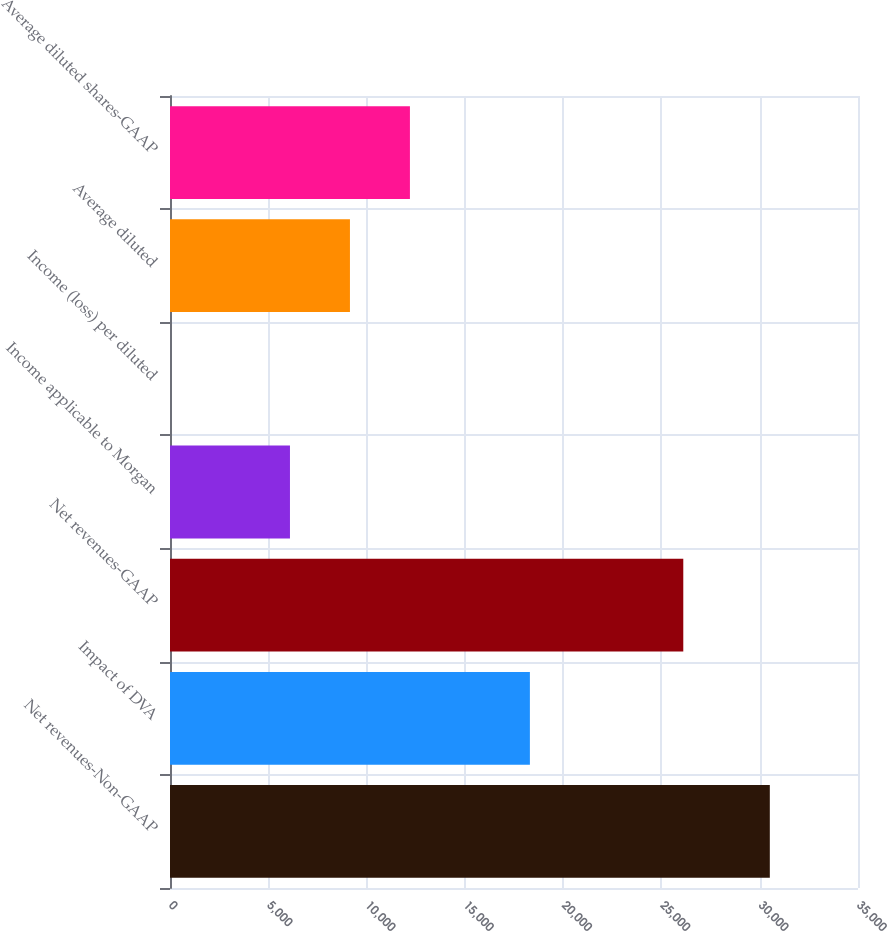Convert chart to OTSL. <chart><loc_0><loc_0><loc_500><loc_500><bar_chart><fcel>Net revenues-Non-GAAP<fcel>Impact of DVA<fcel>Net revenues-GAAP<fcel>Income applicable to Morgan<fcel>Income (loss) per diluted<fcel>Average diluted<fcel>Average diluted shares-GAAP<nl><fcel>30514<fcel>18308.4<fcel>26112<fcel>6102.82<fcel>0.02<fcel>9154.22<fcel>12205.6<nl></chart> 